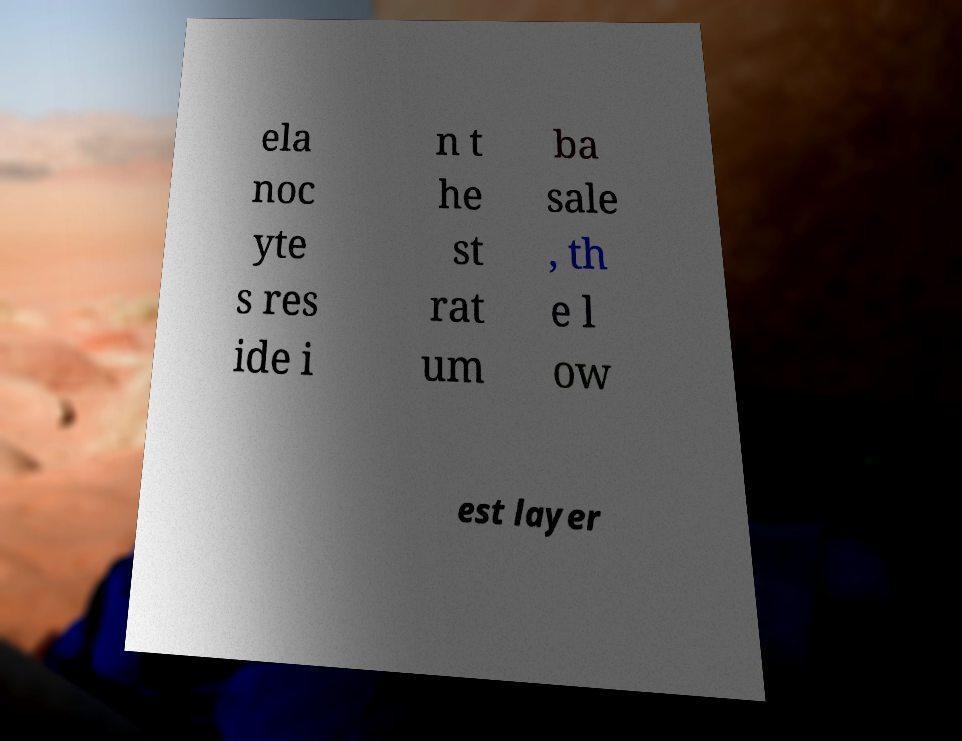Could you assist in decoding the text presented in this image and type it out clearly? ela noc yte s res ide i n t he st rat um ba sale , th e l ow est layer 